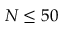<formula> <loc_0><loc_0><loc_500><loc_500>N \leq 5 0</formula> 